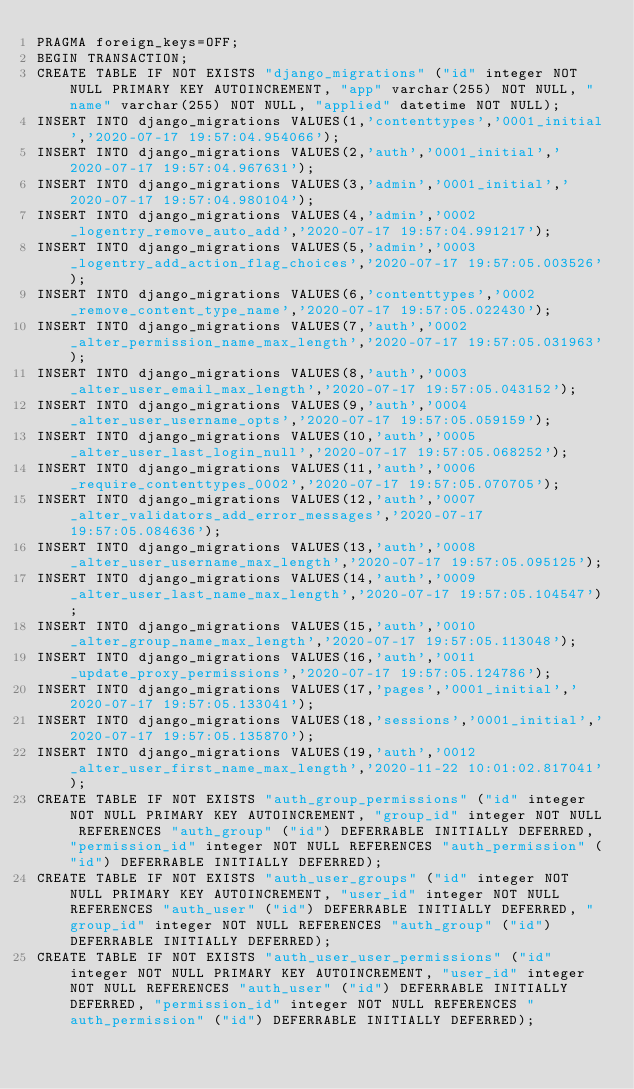Convert code to text. <code><loc_0><loc_0><loc_500><loc_500><_SQL_>PRAGMA foreign_keys=OFF;
BEGIN TRANSACTION;
CREATE TABLE IF NOT EXISTS "django_migrations" ("id" integer NOT NULL PRIMARY KEY AUTOINCREMENT, "app" varchar(255) NOT NULL, "name" varchar(255) NOT NULL, "applied" datetime NOT NULL);
INSERT INTO django_migrations VALUES(1,'contenttypes','0001_initial','2020-07-17 19:57:04.954066');
INSERT INTO django_migrations VALUES(2,'auth','0001_initial','2020-07-17 19:57:04.967631');
INSERT INTO django_migrations VALUES(3,'admin','0001_initial','2020-07-17 19:57:04.980104');
INSERT INTO django_migrations VALUES(4,'admin','0002_logentry_remove_auto_add','2020-07-17 19:57:04.991217');
INSERT INTO django_migrations VALUES(5,'admin','0003_logentry_add_action_flag_choices','2020-07-17 19:57:05.003526');
INSERT INTO django_migrations VALUES(6,'contenttypes','0002_remove_content_type_name','2020-07-17 19:57:05.022430');
INSERT INTO django_migrations VALUES(7,'auth','0002_alter_permission_name_max_length','2020-07-17 19:57:05.031963');
INSERT INTO django_migrations VALUES(8,'auth','0003_alter_user_email_max_length','2020-07-17 19:57:05.043152');
INSERT INTO django_migrations VALUES(9,'auth','0004_alter_user_username_opts','2020-07-17 19:57:05.059159');
INSERT INTO django_migrations VALUES(10,'auth','0005_alter_user_last_login_null','2020-07-17 19:57:05.068252');
INSERT INTO django_migrations VALUES(11,'auth','0006_require_contenttypes_0002','2020-07-17 19:57:05.070705');
INSERT INTO django_migrations VALUES(12,'auth','0007_alter_validators_add_error_messages','2020-07-17 19:57:05.084636');
INSERT INTO django_migrations VALUES(13,'auth','0008_alter_user_username_max_length','2020-07-17 19:57:05.095125');
INSERT INTO django_migrations VALUES(14,'auth','0009_alter_user_last_name_max_length','2020-07-17 19:57:05.104547');
INSERT INTO django_migrations VALUES(15,'auth','0010_alter_group_name_max_length','2020-07-17 19:57:05.113048');
INSERT INTO django_migrations VALUES(16,'auth','0011_update_proxy_permissions','2020-07-17 19:57:05.124786');
INSERT INTO django_migrations VALUES(17,'pages','0001_initial','2020-07-17 19:57:05.133041');
INSERT INTO django_migrations VALUES(18,'sessions','0001_initial','2020-07-17 19:57:05.135870');
INSERT INTO django_migrations VALUES(19,'auth','0012_alter_user_first_name_max_length','2020-11-22 10:01:02.817041');
CREATE TABLE IF NOT EXISTS "auth_group_permissions" ("id" integer NOT NULL PRIMARY KEY AUTOINCREMENT, "group_id" integer NOT NULL REFERENCES "auth_group" ("id") DEFERRABLE INITIALLY DEFERRED, "permission_id" integer NOT NULL REFERENCES "auth_permission" ("id") DEFERRABLE INITIALLY DEFERRED);
CREATE TABLE IF NOT EXISTS "auth_user_groups" ("id" integer NOT NULL PRIMARY KEY AUTOINCREMENT, "user_id" integer NOT NULL REFERENCES "auth_user" ("id") DEFERRABLE INITIALLY DEFERRED, "group_id" integer NOT NULL REFERENCES "auth_group" ("id") DEFERRABLE INITIALLY DEFERRED);
CREATE TABLE IF NOT EXISTS "auth_user_user_permissions" ("id" integer NOT NULL PRIMARY KEY AUTOINCREMENT, "user_id" integer NOT NULL REFERENCES "auth_user" ("id") DEFERRABLE INITIALLY DEFERRED, "permission_id" integer NOT NULL REFERENCES "auth_permission" ("id") DEFERRABLE INITIALLY DEFERRED);</code> 